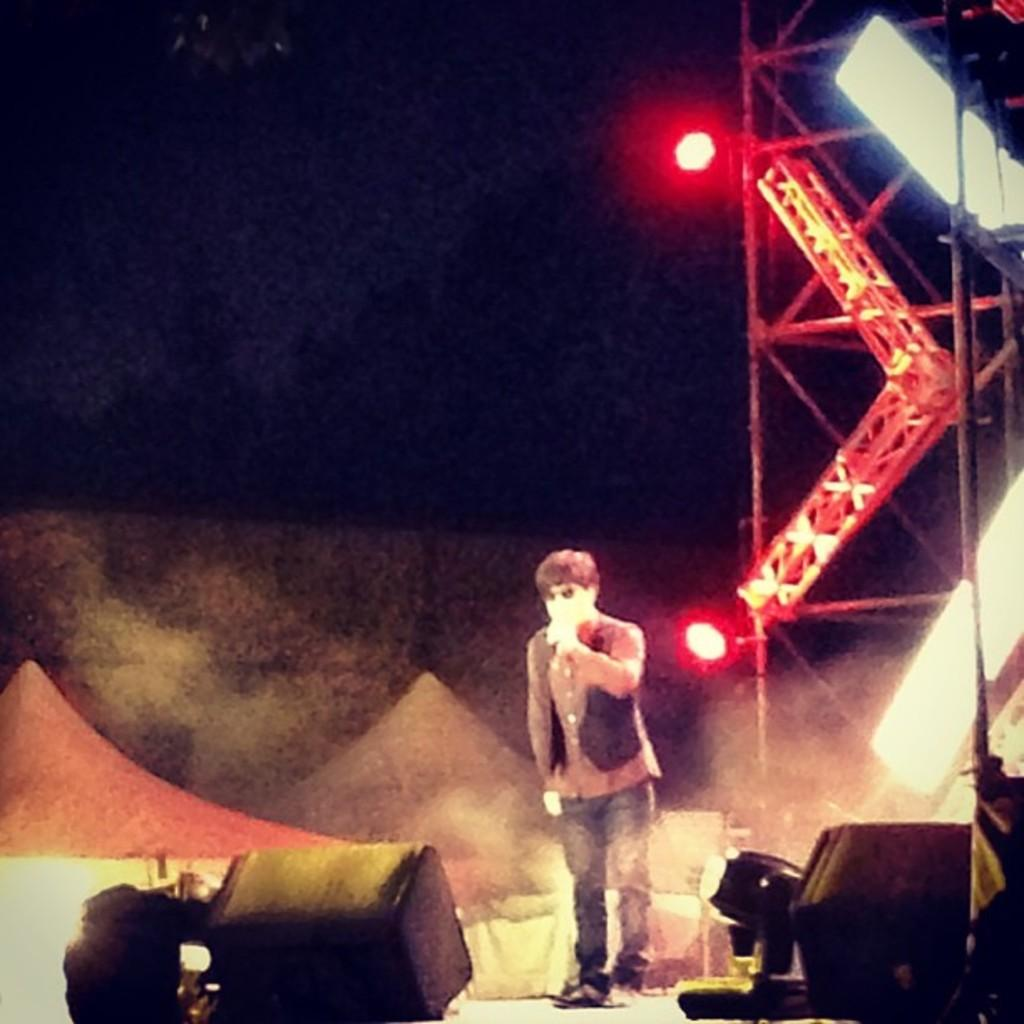What is the main subject of the image? There is a man standing in the image. What can be seen on the right side of the image? There are lights and rods on the right side of the image. What color is the crayon being used by the man in the image? There is no crayon present in the image. How many shoes can be seen on the man's feet in the image? The image does not show the man's feet, so it is not possible to determine the number of shoes he is wearing. 